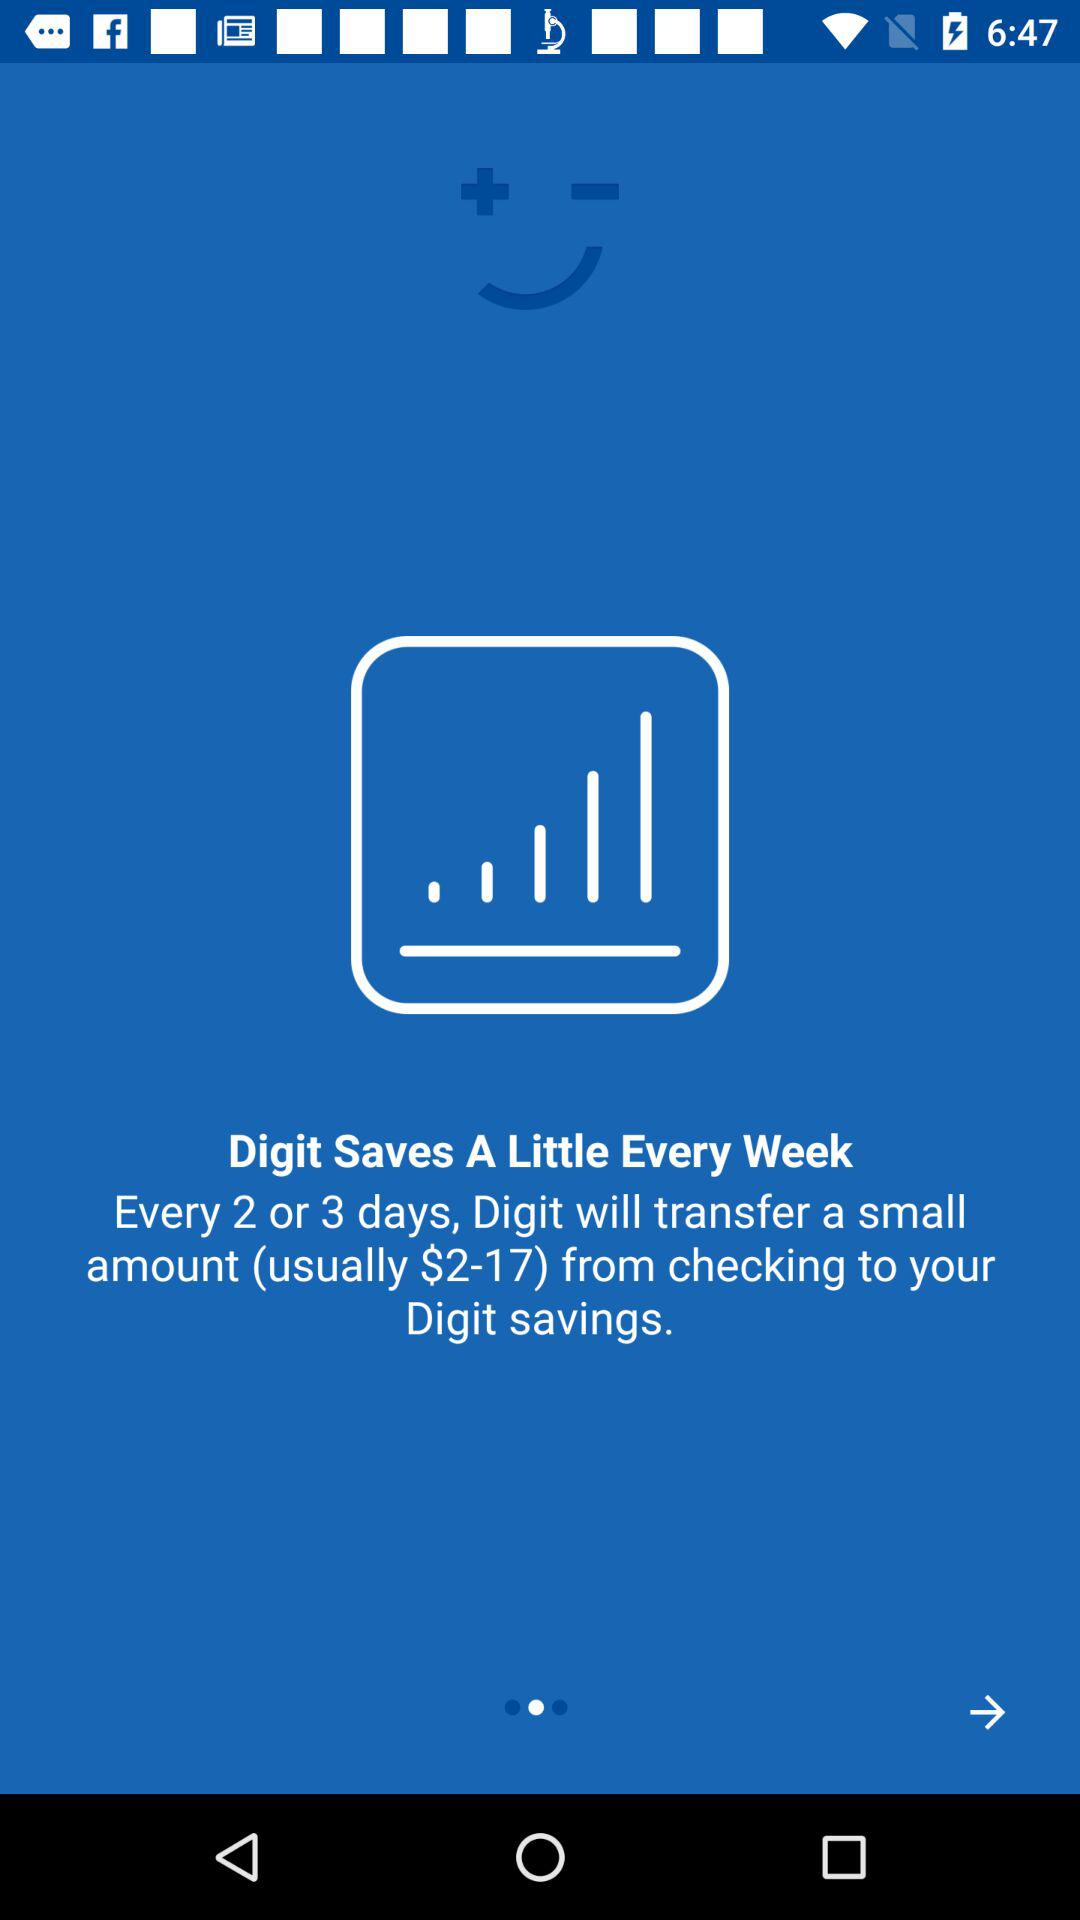How many dollars more is the maximum amount Digit will transfer than the minimum amount?
Answer the question using a single word or phrase. 15 